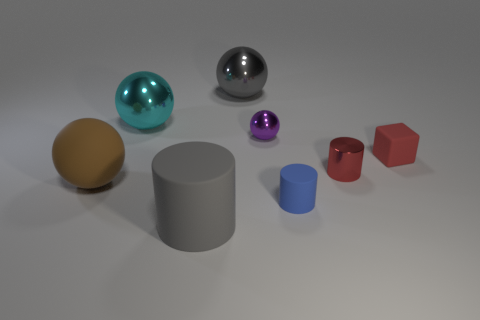Subtract all brown balls. How many balls are left? 3 Subtract all blue cylinders. How many cylinders are left? 2 Subtract 1 balls. How many balls are left? 3 Add 1 tiny purple metallic things. How many objects exist? 9 Subtract all cubes. How many objects are left? 7 Subtract all brown cubes. How many gray cylinders are left? 1 Subtract all brown cylinders. Subtract all big cyan spheres. How many objects are left? 7 Add 2 tiny purple metal things. How many tiny purple metal things are left? 3 Add 2 big things. How many big things exist? 6 Subtract 1 blue cylinders. How many objects are left? 7 